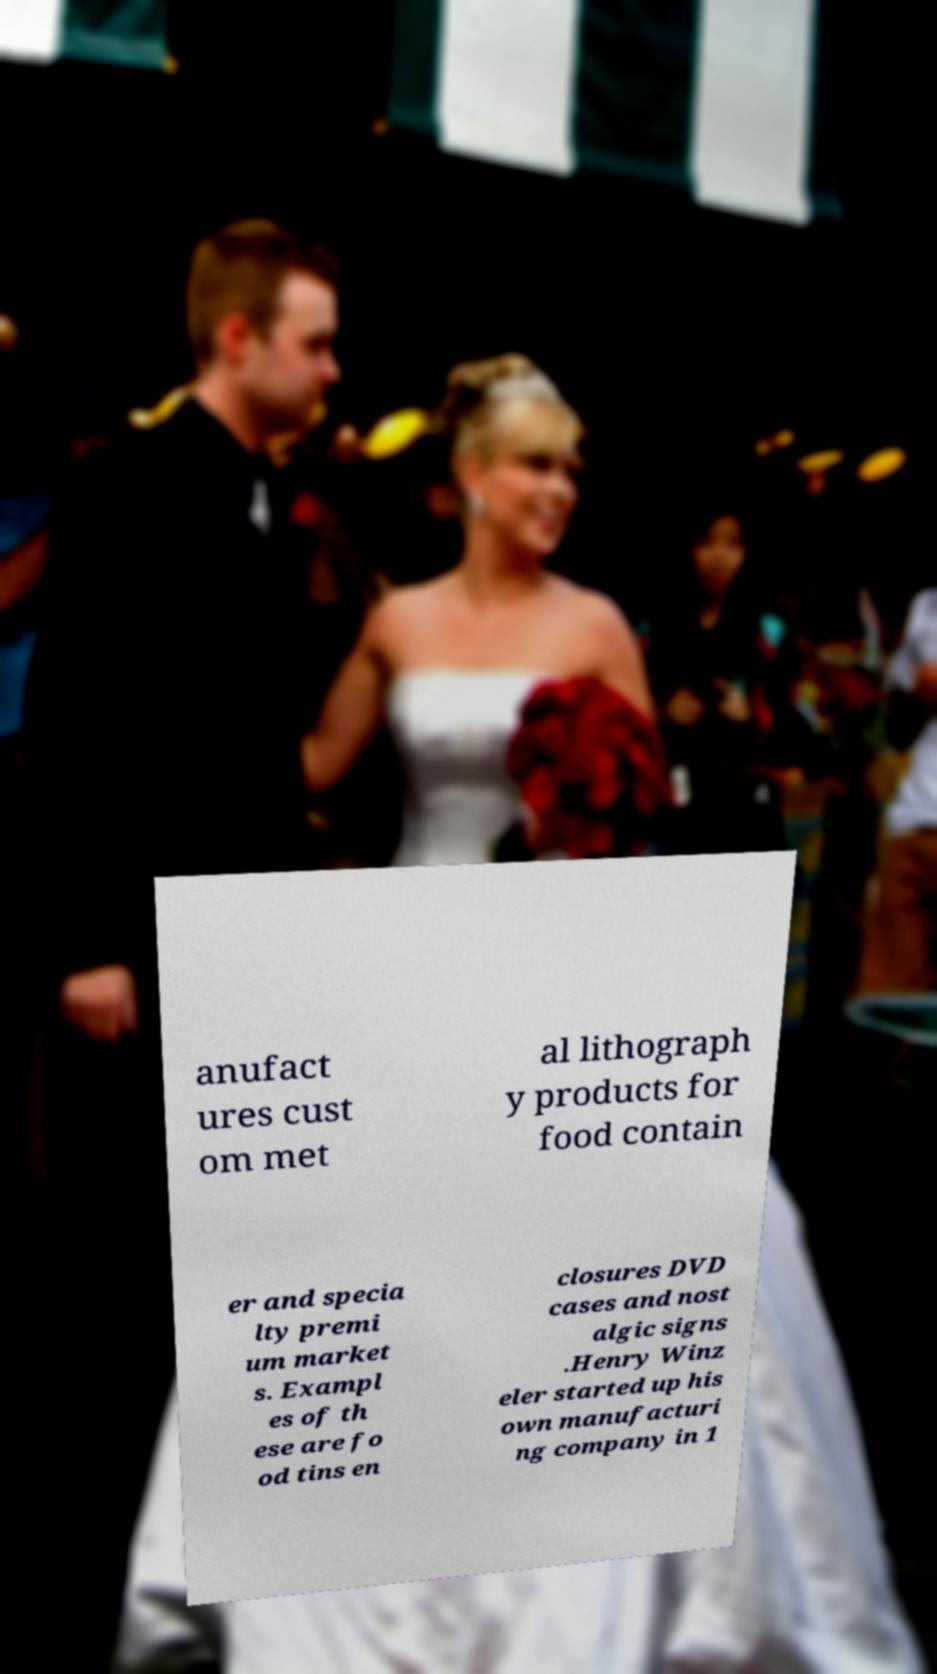I need the written content from this picture converted into text. Can you do that? anufact ures cust om met al lithograph y products for food contain er and specia lty premi um market s. Exampl es of th ese are fo od tins en closures DVD cases and nost algic signs .Henry Winz eler started up his own manufacturi ng company in 1 